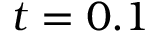Convert formula to latex. <formula><loc_0><loc_0><loc_500><loc_500>t = 0 . 1</formula> 